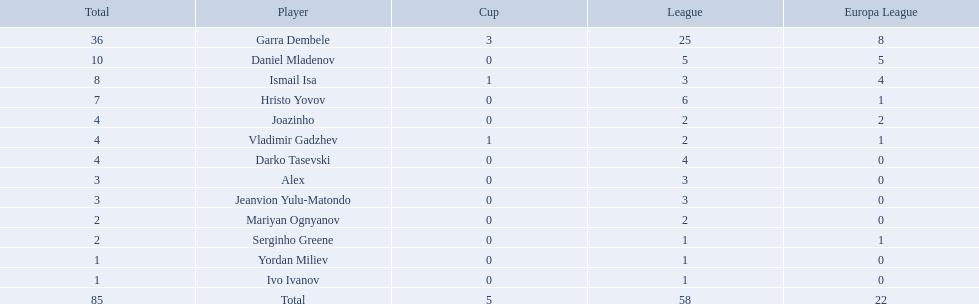Who are all of the players? Garra Dembele, Daniel Mladenov, Ismail Isa, Hristo Yovov, Joazinho, Vladimir Gadzhev, Darko Tasevski, Alex, Jeanvion Yulu-Matondo, Mariyan Ognyanov, Serginho Greene, Yordan Miliev, Ivo Ivanov. And which league is each player in? 25, 5, 3, 6, 2, 2, 4, 3, 3, 2, 1, 1, 1. Along with vladimir gadzhev and joazinho, which other player is in league 2? Mariyan Ognyanov. 